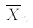<formula> <loc_0><loc_0><loc_500><loc_500>\overline { X } _ { n }</formula> 